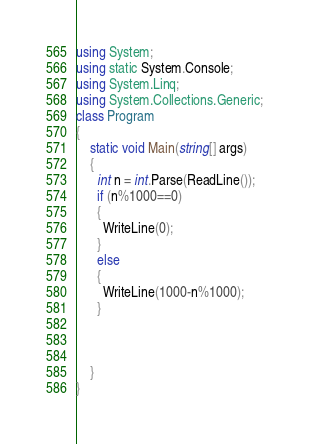Convert code to text. <code><loc_0><loc_0><loc_500><loc_500><_C#_>using System;
using static System.Console;
using System.Linq;
using System.Collections.Generic;
class Program
{
    static void Main(string[] args)
    {
      int n = int.Parse(ReadLine());
      if (n%1000==0)
      {
        WriteLine(0);
      }
      else
      {
        WriteLine(1000-n%1000);
      }
      
      
      
    }
}</code> 